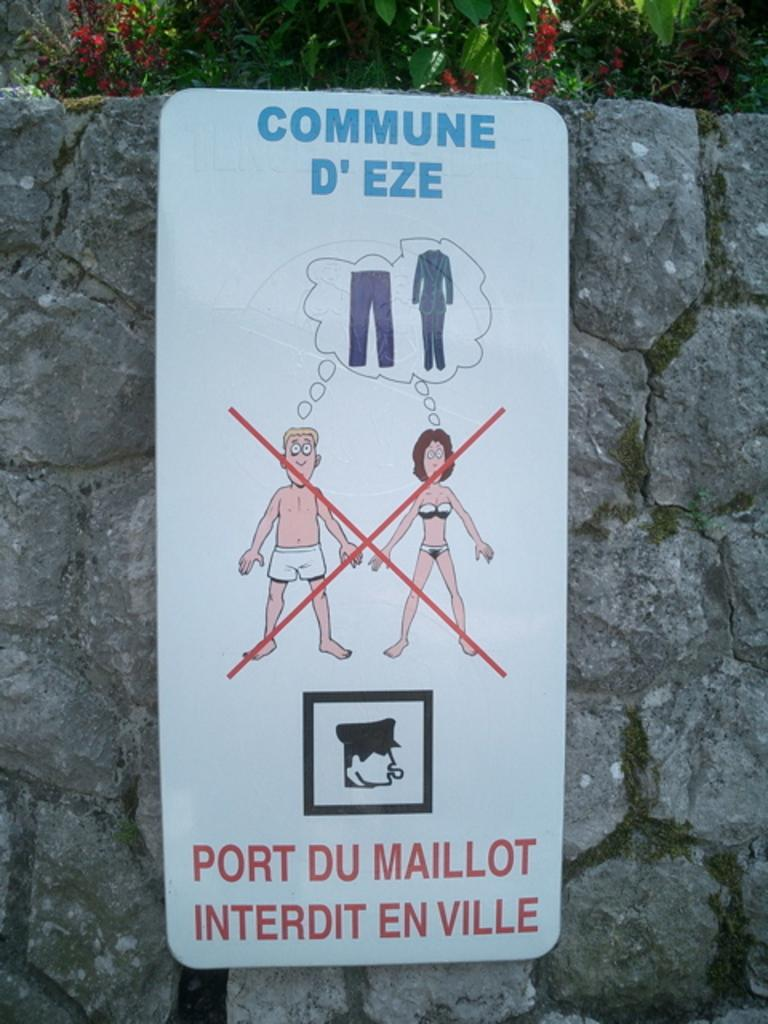What is on the wall in the image? There is a poster on the wall in the image. What can be seen in the background of the image? There are trees visible in the background of the image. How many rings are hanging from the branches of the trees in the image? There are no rings visible on the trees in the image. Is there any sleet falling in the image? There is no indication of sleet in the image. Can you see a rifle in the image? There is no rifle present in the image. 